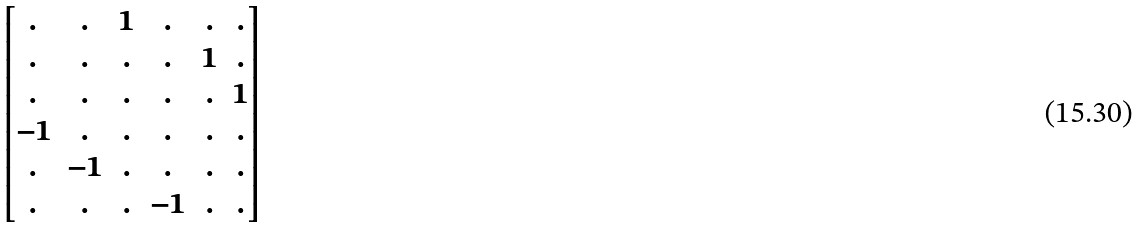Convert formula to latex. <formula><loc_0><loc_0><loc_500><loc_500>\begin{bmatrix} . & . & 1 & . & . & . \\ . & . & . & . & 1 & . \\ . & . & . & . & . & 1 \\ - 1 & . & . & . & . & . \\ . & - 1 & . & . & . & . \\ . & . & . & - 1 & . & . \end{bmatrix}</formula> 